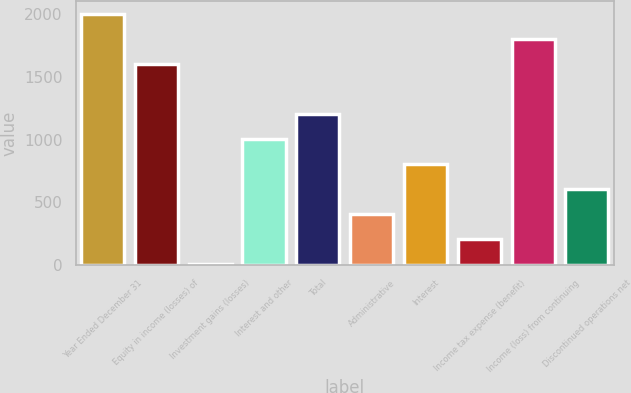<chart> <loc_0><loc_0><loc_500><loc_500><bar_chart><fcel>Year Ended December 31<fcel>Equity in income (losses) of<fcel>Investment gains (losses)<fcel>Interest and other<fcel>Total<fcel>Administrative<fcel>Interest<fcel>Income tax expense (benefit)<fcel>Income (loss) from continuing<fcel>Discontinued operations net<nl><fcel>2003<fcel>1603.86<fcel>7.3<fcel>1005.15<fcel>1204.72<fcel>406.44<fcel>805.58<fcel>206.87<fcel>1803.43<fcel>606.01<nl></chart> 